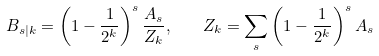<formula> <loc_0><loc_0><loc_500><loc_500>B _ { s | k } = \left ( 1 - \frac { 1 } { 2 ^ { k } } \right ) ^ { s } \frac { A _ { s } } { Z _ { k } } , \quad Z _ { k } = \sum _ { s } \left ( 1 - \frac { 1 } { 2 ^ { k } } \right ) ^ { s } A _ { s }</formula> 